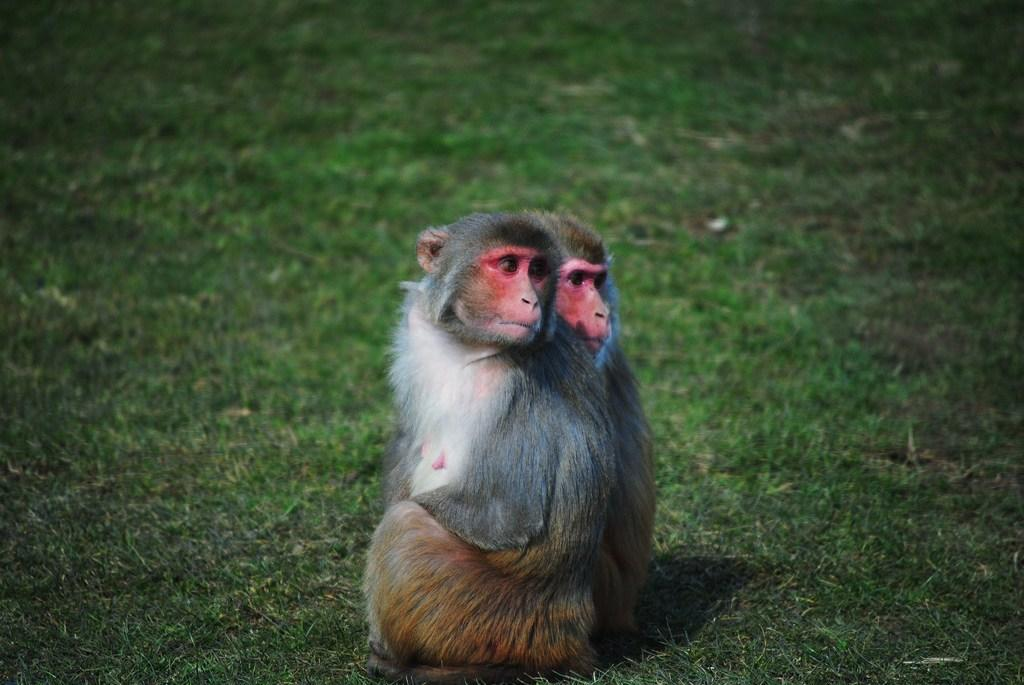What type of animal is in the image? There is a two-faced monkey in the image. Where is the monkey located? The monkey is on the grass. What type of trail can be seen in the image? There is no trail present in the image; it features a two-faced monkey on the grass. What type of street is visible in the image? There is no street present in the image; it features a two-faced monkey on the grass. 